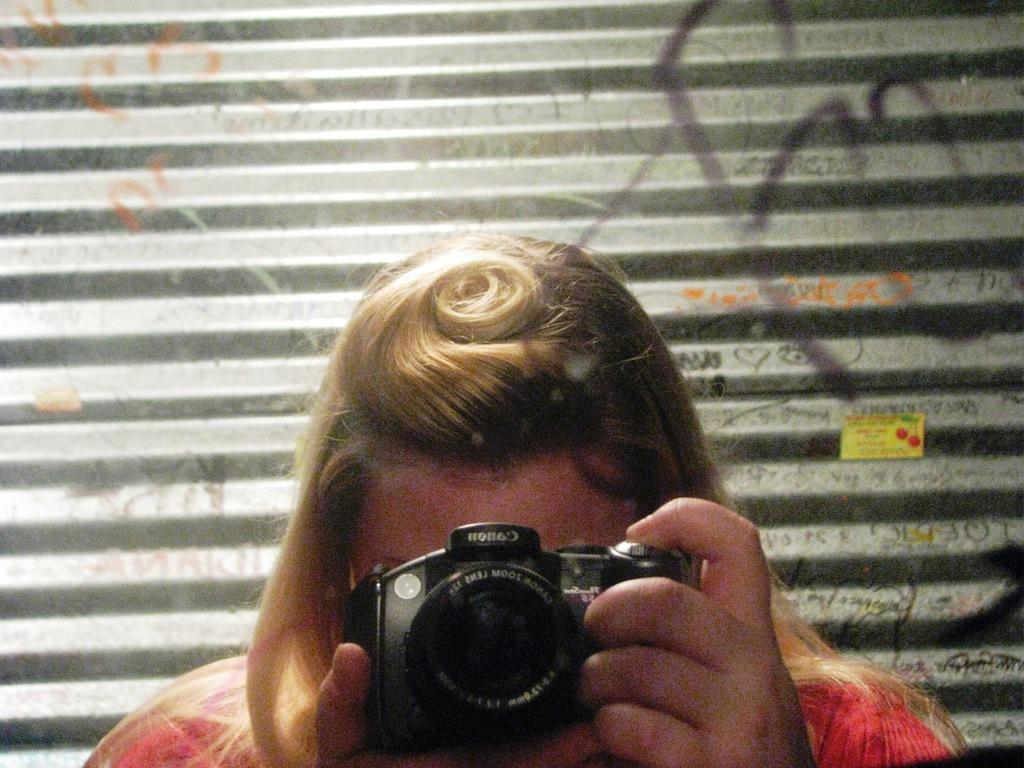Who is the main subject in the image? There is a woman in the image. What is the woman holding in the image? The woman is holding a camera. What can be seen in the background of the image? There is a metal shutter in the background of the image. What is written or depicted on the metal shutter? There is some text on the metal shutter. What type of furniture is visible in the image? There is no furniture visible in the image. How does the acoustics of the room affect the sound of the woman's camera shutter? The image does not provide any information about the acoustics of the room, so it is impossible to determine how it might affect the sound of the camera shutter. 